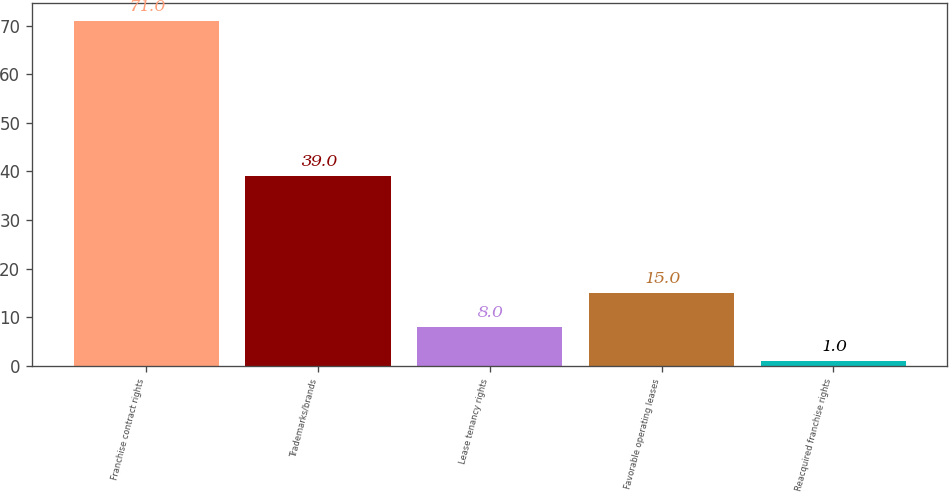Convert chart to OTSL. <chart><loc_0><loc_0><loc_500><loc_500><bar_chart><fcel>Franchise contract rights<fcel>Trademarks/brands<fcel>Lease tenancy rights<fcel>Favorable operating leases<fcel>Reacquired franchise rights<nl><fcel>71<fcel>39<fcel>8<fcel>15<fcel>1<nl></chart> 